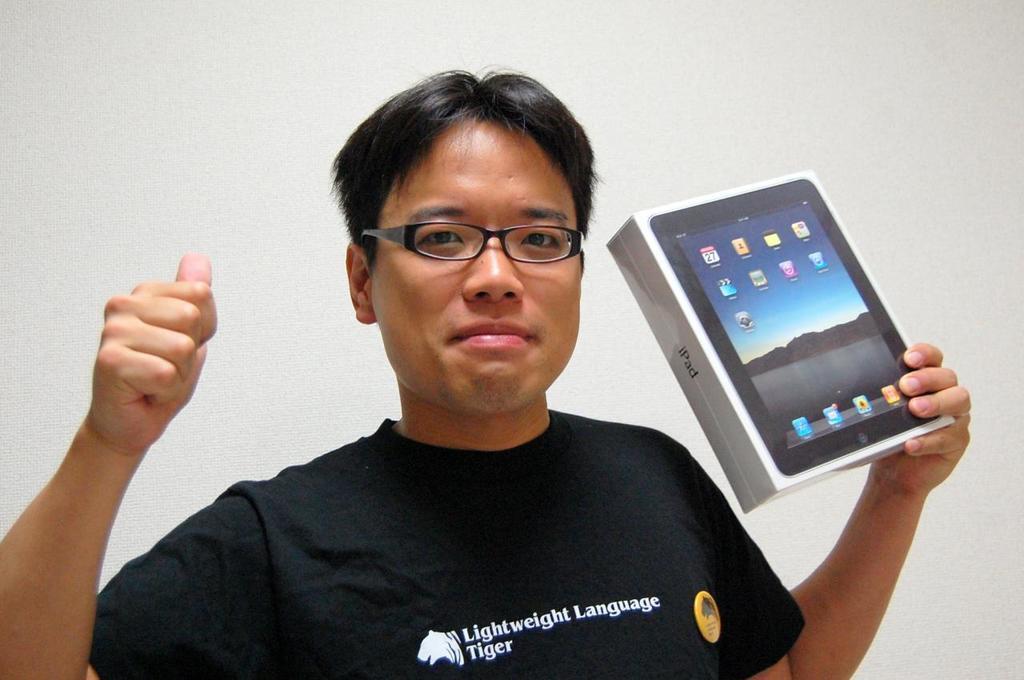How would you summarize this image in a sentence or two? In this picture we can see man wore black color T-Shirt, spectacle holding box in one hand and in background we can see wall. 